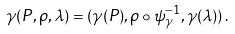<formula> <loc_0><loc_0><loc_500><loc_500>\gamma ( P , \rho , \lambda ) = ( \gamma ( P ) , \rho \circ \psi _ { \gamma } ^ { - 1 } , \gamma ( \lambda ) ) \, .</formula> 